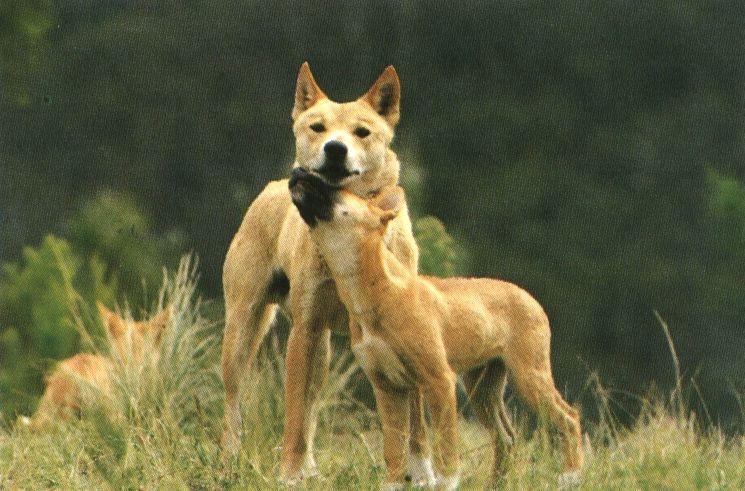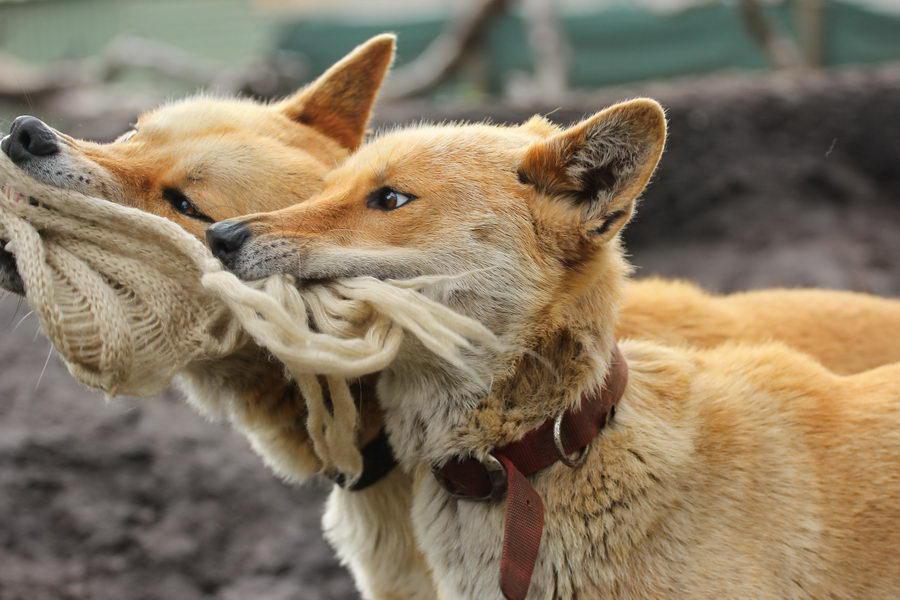The first image is the image on the left, the second image is the image on the right. Given the left and right images, does the statement "One dog is touching another dogs chin with its head." hold true? Answer yes or no. Yes. The first image is the image on the left, the second image is the image on the right. Examine the images to the left and right. Is the description "There is at most 2 dingoes." accurate? Answer yes or no. No. 